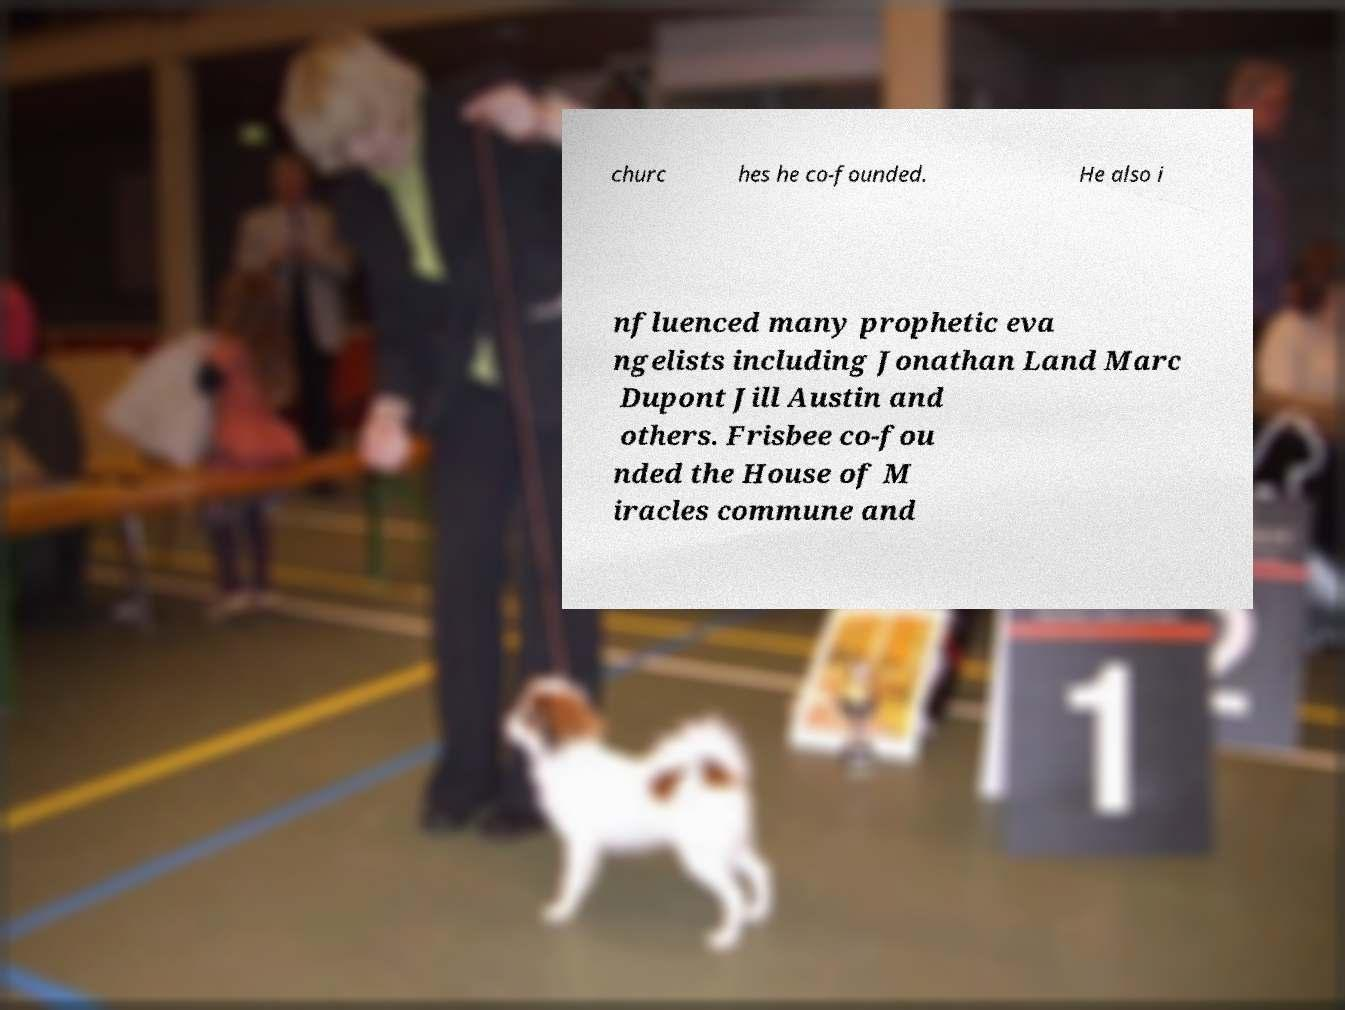Can you read and provide the text displayed in the image?This photo seems to have some interesting text. Can you extract and type it out for me? churc hes he co-founded. He also i nfluenced many prophetic eva ngelists including Jonathan Land Marc Dupont Jill Austin and others. Frisbee co-fou nded the House of M iracles commune and 